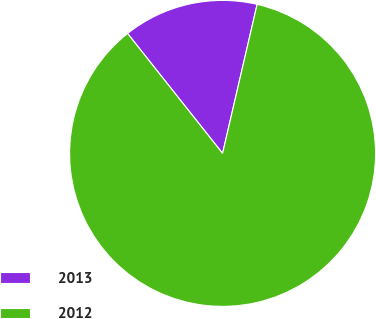<chart> <loc_0><loc_0><loc_500><loc_500><pie_chart><fcel>2013<fcel>2012<nl><fcel>14.29%<fcel>85.71%<nl></chart> 